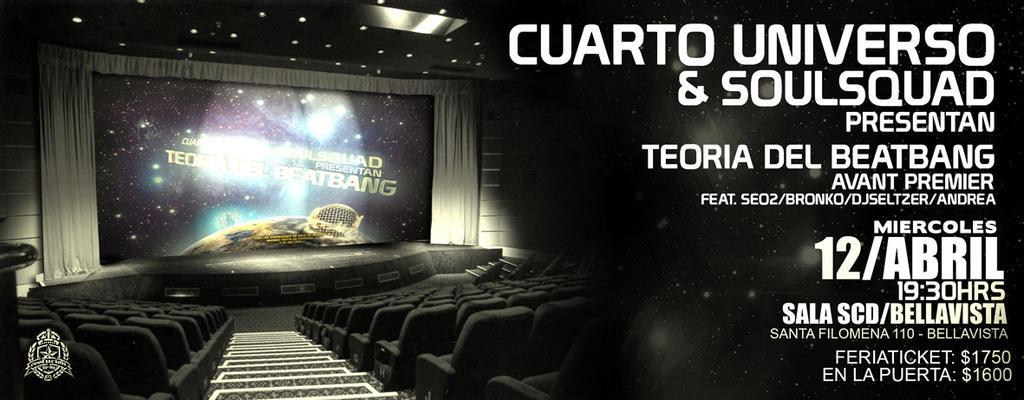Describe this image in one or two sentences. These are chairs, this is screen. 